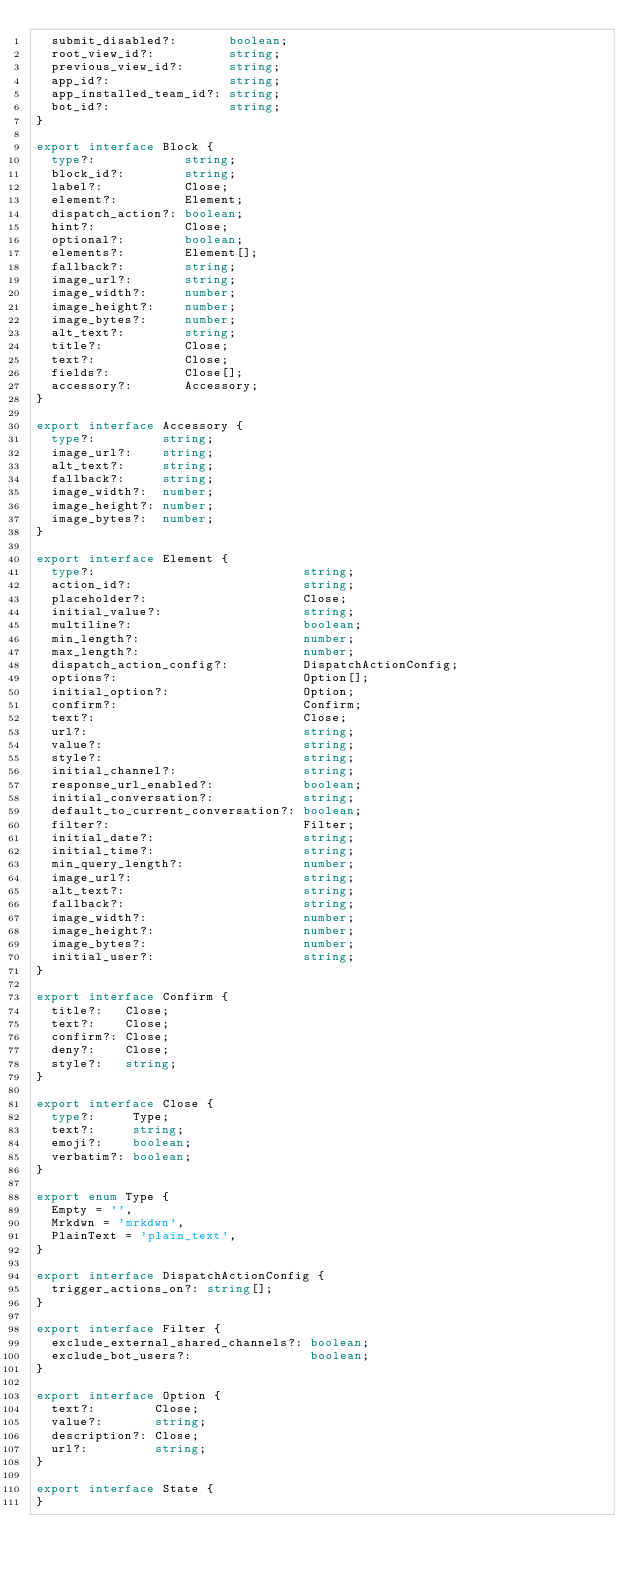Convert code to text. <code><loc_0><loc_0><loc_500><loc_500><_TypeScript_>  submit_disabled?:       boolean;
  root_view_id?:          string;
  previous_view_id?:      string;
  app_id?:                string;
  app_installed_team_id?: string;
  bot_id?:                string;
}

export interface Block {
  type?:            string;
  block_id?:        string;
  label?:           Close;
  element?:         Element;
  dispatch_action?: boolean;
  hint?:            Close;
  optional?:        boolean;
  elements?:        Element[];
  fallback?:        string;
  image_url?:       string;
  image_width?:     number;
  image_height?:    number;
  image_bytes?:     number;
  alt_text?:        string;
  title?:           Close;
  text?:            Close;
  fields?:          Close[];
  accessory?:       Accessory;
}

export interface Accessory {
  type?:         string;
  image_url?:    string;
  alt_text?:     string;
  fallback?:     string;
  image_width?:  number;
  image_height?: number;
  image_bytes?:  number;
}

export interface Element {
  type?:                            string;
  action_id?:                       string;
  placeholder?:                     Close;
  initial_value?:                   string;
  multiline?:                       boolean;
  min_length?:                      number;
  max_length?:                      number;
  dispatch_action_config?:          DispatchActionConfig;
  options?:                         Option[];
  initial_option?:                  Option;
  confirm?:                         Confirm;
  text?:                            Close;
  url?:                             string;
  value?:                           string;
  style?:                           string;
  initial_channel?:                 string;
  response_url_enabled?:            boolean;
  initial_conversation?:            string;
  default_to_current_conversation?: boolean;
  filter?:                          Filter;
  initial_date?:                    string;
  initial_time?:                    string;
  min_query_length?:                number;
  image_url?:                       string;
  alt_text?:                        string;
  fallback?:                        string;
  image_width?:                     number;
  image_height?:                    number;
  image_bytes?:                     number;
  initial_user?:                    string;
}

export interface Confirm {
  title?:   Close;
  text?:    Close;
  confirm?: Close;
  deny?:    Close;
  style?:   string;
}

export interface Close {
  type?:     Type;
  text?:     string;
  emoji?:    boolean;
  verbatim?: boolean;
}

export enum Type {
  Empty = '',
  Mrkdwn = 'mrkdwn',
  PlainText = 'plain_text',
}

export interface DispatchActionConfig {
  trigger_actions_on?: string[];
}

export interface Filter {
  exclude_external_shared_channels?: boolean;
  exclude_bot_users?:                boolean;
}

export interface Option {
  text?:        Close;
  value?:       string;
  description?: Close;
  url?:         string;
}

export interface State {
}
</code> 